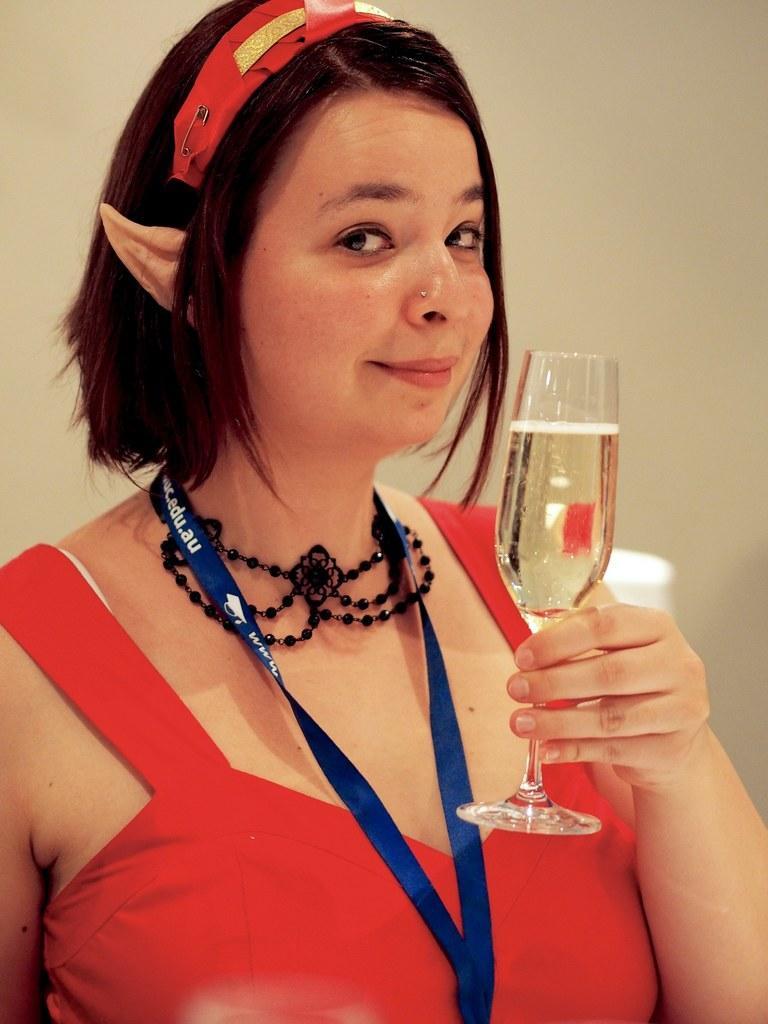How would you summarize this image in a sentence or two? In this image there is a woman with red dress and she is smiling and she is holding a glass. 